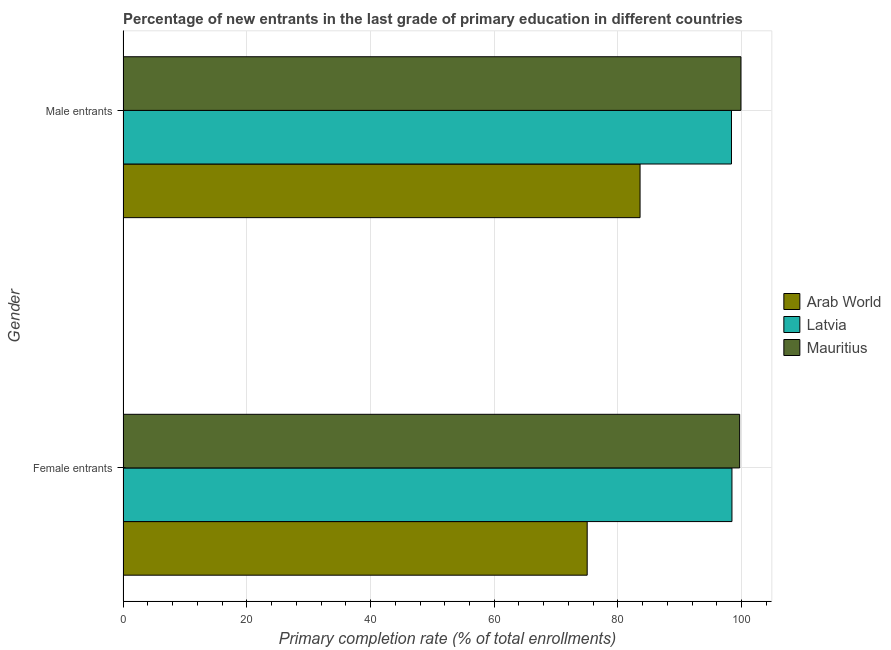How many different coloured bars are there?
Your answer should be very brief. 3. Are the number of bars per tick equal to the number of legend labels?
Offer a terse response. Yes. How many bars are there on the 1st tick from the top?
Provide a succinct answer. 3. How many bars are there on the 1st tick from the bottom?
Keep it short and to the point. 3. What is the label of the 2nd group of bars from the top?
Provide a succinct answer. Female entrants. What is the primary completion rate of female entrants in Mauritius?
Provide a succinct answer. 99.66. Across all countries, what is the maximum primary completion rate of male entrants?
Ensure brevity in your answer.  99.87. Across all countries, what is the minimum primary completion rate of female entrants?
Give a very brief answer. 75.02. In which country was the primary completion rate of male entrants maximum?
Provide a short and direct response. Mauritius. In which country was the primary completion rate of female entrants minimum?
Your response must be concise. Arab World. What is the total primary completion rate of female entrants in the graph?
Give a very brief answer. 273.1. What is the difference between the primary completion rate of female entrants in Arab World and that in Latvia?
Give a very brief answer. -23.4. What is the difference between the primary completion rate of female entrants in Mauritius and the primary completion rate of male entrants in Latvia?
Ensure brevity in your answer.  1.32. What is the average primary completion rate of male entrants per country?
Your answer should be very brief. 93.93. What is the difference between the primary completion rate of female entrants and primary completion rate of male entrants in Latvia?
Give a very brief answer. 0.08. What is the ratio of the primary completion rate of male entrants in Latvia to that in Mauritius?
Ensure brevity in your answer.  0.98. Is the primary completion rate of female entrants in Latvia less than that in Arab World?
Offer a terse response. No. In how many countries, is the primary completion rate of female entrants greater than the average primary completion rate of female entrants taken over all countries?
Offer a terse response. 2. What does the 1st bar from the top in Male entrants represents?
Your response must be concise. Mauritius. What does the 1st bar from the bottom in Male entrants represents?
Offer a very short reply. Arab World. How many bars are there?
Ensure brevity in your answer.  6. Are all the bars in the graph horizontal?
Your response must be concise. Yes. How many countries are there in the graph?
Keep it short and to the point. 3. Does the graph contain any zero values?
Offer a very short reply. No. Does the graph contain grids?
Offer a very short reply. Yes. How many legend labels are there?
Your response must be concise. 3. What is the title of the graph?
Ensure brevity in your answer.  Percentage of new entrants in the last grade of primary education in different countries. What is the label or title of the X-axis?
Ensure brevity in your answer.  Primary completion rate (% of total enrollments). What is the label or title of the Y-axis?
Give a very brief answer. Gender. What is the Primary completion rate (% of total enrollments) in Arab World in Female entrants?
Keep it short and to the point. 75.02. What is the Primary completion rate (% of total enrollments) in Latvia in Female entrants?
Provide a succinct answer. 98.42. What is the Primary completion rate (% of total enrollments) of Mauritius in Female entrants?
Keep it short and to the point. 99.66. What is the Primary completion rate (% of total enrollments) in Arab World in Male entrants?
Offer a terse response. 83.57. What is the Primary completion rate (% of total enrollments) of Latvia in Male entrants?
Give a very brief answer. 98.34. What is the Primary completion rate (% of total enrollments) of Mauritius in Male entrants?
Your answer should be compact. 99.87. Across all Gender, what is the maximum Primary completion rate (% of total enrollments) of Arab World?
Your answer should be compact. 83.57. Across all Gender, what is the maximum Primary completion rate (% of total enrollments) in Latvia?
Ensure brevity in your answer.  98.42. Across all Gender, what is the maximum Primary completion rate (% of total enrollments) of Mauritius?
Give a very brief answer. 99.87. Across all Gender, what is the minimum Primary completion rate (% of total enrollments) of Arab World?
Your answer should be compact. 75.02. Across all Gender, what is the minimum Primary completion rate (% of total enrollments) of Latvia?
Keep it short and to the point. 98.34. Across all Gender, what is the minimum Primary completion rate (% of total enrollments) of Mauritius?
Your response must be concise. 99.66. What is the total Primary completion rate (% of total enrollments) in Arab World in the graph?
Provide a short and direct response. 158.59. What is the total Primary completion rate (% of total enrollments) of Latvia in the graph?
Make the answer very short. 196.76. What is the total Primary completion rate (% of total enrollments) in Mauritius in the graph?
Ensure brevity in your answer.  199.53. What is the difference between the Primary completion rate (% of total enrollments) of Arab World in Female entrants and that in Male entrants?
Your answer should be compact. -8.54. What is the difference between the Primary completion rate (% of total enrollments) of Latvia in Female entrants and that in Male entrants?
Your answer should be compact. 0.08. What is the difference between the Primary completion rate (% of total enrollments) of Mauritius in Female entrants and that in Male entrants?
Make the answer very short. -0.21. What is the difference between the Primary completion rate (% of total enrollments) in Arab World in Female entrants and the Primary completion rate (% of total enrollments) in Latvia in Male entrants?
Give a very brief answer. -23.32. What is the difference between the Primary completion rate (% of total enrollments) in Arab World in Female entrants and the Primary completion rate (% of total enrollments) in Mauritius in Male entrants?
Your answer should be very brief. -24.85. What is the difference between the Primary completion rate (% of total enrollments) of Latvia in Female entrants and the Primary completion rate (% of total enrollments) of Mauritius in Male entrants?
Your answer should be compact. -1.45. What is the average Primary completion rate (% of total enrollments) of Arab World per Gender?
Your answer should be compact. 79.29. What is the average Primary completion rate (% of total enrollments) in Latvia per Gender?
Give a very brief answer. 98.38. What is the average Primary completion rate (% of total enrollments) in Mauritius per Gender?
Make the answer very short. 99.77. What is the difference between the Primary completion rate (% of total enrollments) of Arab World and Primary completion rate (% of total enrollments) of Latvia in Female entrants?
Keep it short and to the point. -23.4. What is the difference between the Primary completion rate (% of total enrollments) of Arab World and Primary completion rate (% of total enrollments) of Mauritius in Female entrants?
Make the answer very short. -24.64. What is the difference between the Primary completion rate (% of total enrollments) in Latvia and Primary completion rate (% of total enrollments) in Mauritius in Female entrants?
Make the answer very short. -1.24. What is the difference between the Primary completion rate (% of total enrollments) of Arab World and Primary completion rate (% of total enrollments) of Latvia in Male entrants?
Your answer should be compact. -14.78. What is the difference between the Primary completion rate (% of total enrollments) in Arab World and Primary completion rate (% of total enrollments) in Mauritius in Male entrants?
Keep it short and to the point. -16.3. What is the difference between the Primary completion rate (% of total enrollments) of Latvia and Primary completion rate (% of total enrollments) of Mauritius in Male entrants?
Make the answer very short. -1.53. What is the ratio of the Primary completion rate (% of total enrollments) in Arab World in Female entrants to that in Male entrants?
Provide a succinct answer. 0.9. What is the difference between the highest and the second highest Primary completion rate (% of total enrollments) in Arab World?
Offer a terse response. 8.54. What is the difference between the highest and the second highest Primary completion rate (% of total enrollments) of Latvia?
Offer a terse response. 0.08. What is the difference between the highest and the second highest Primary completion rate (% of total enrollments) of Mauritius?
Offer a terse response. 0.21. What is the difference between the highest and the lowest Primary completion rate (% of total enrollments) in Arab World?
Offer a very short reply. 8.54. What is the difference between the highest and the lowest Primary completion rate (% of total enrollments) of Latvia?
Offer a very short reply. 0.08. What is the difference between the highest and the lowest Primary completion rate (% of total enrollments) of Mauritius?
Your answer should be very brief. 0.21. 